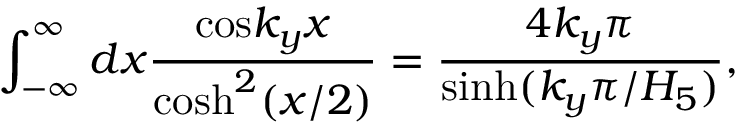<formula> <loc_0><loc_0><loc_500><loc_500>\int _ { - \infty } ^ { \infty } d x { \frac { \cos { k _ { y } x } } { \cosh ^ { 2 } ( x / 2 ) } } = { \frac { 4 k _ { y } \pi } { \sinh ( k _ { y } \pi / H _ { 5 } ) } } ,</formula> 